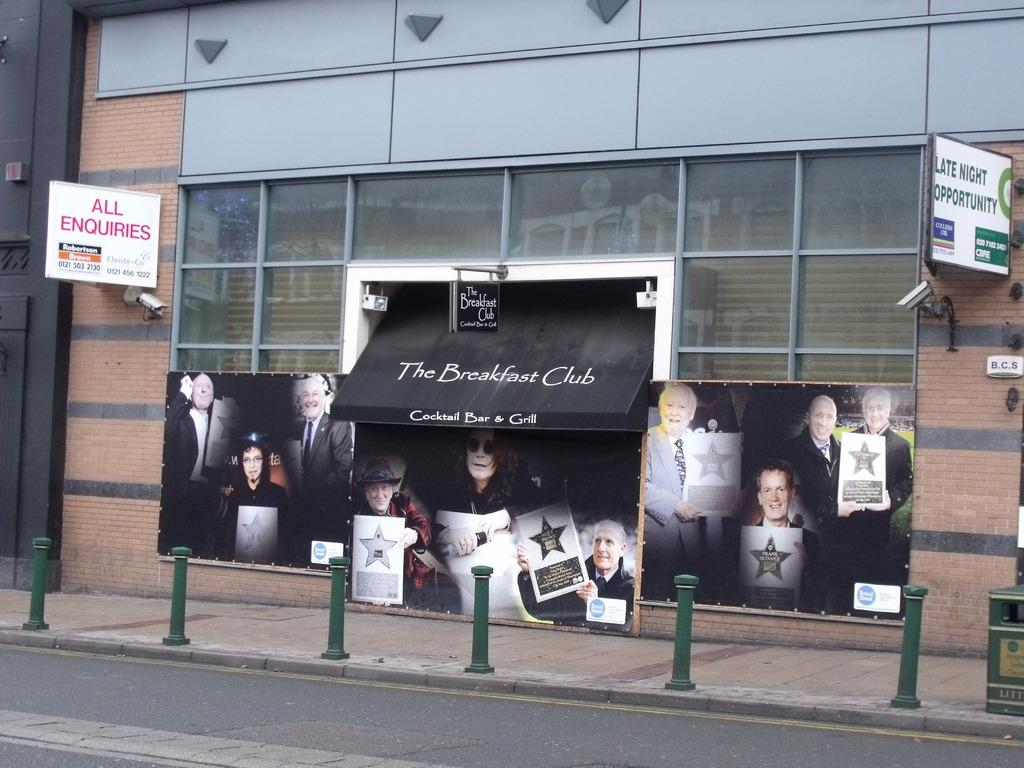What is attached to the wall in the image? There are boards on the wall in the image. What can be seen beside the road in the image? There are poles beside the road in the image. Where is the trash bin located in the image? The trash bin is in the bottom right of the image. What language is spoken by the crib in the image? There is no crib present in the image, and therefore no language can be attributed to it. 